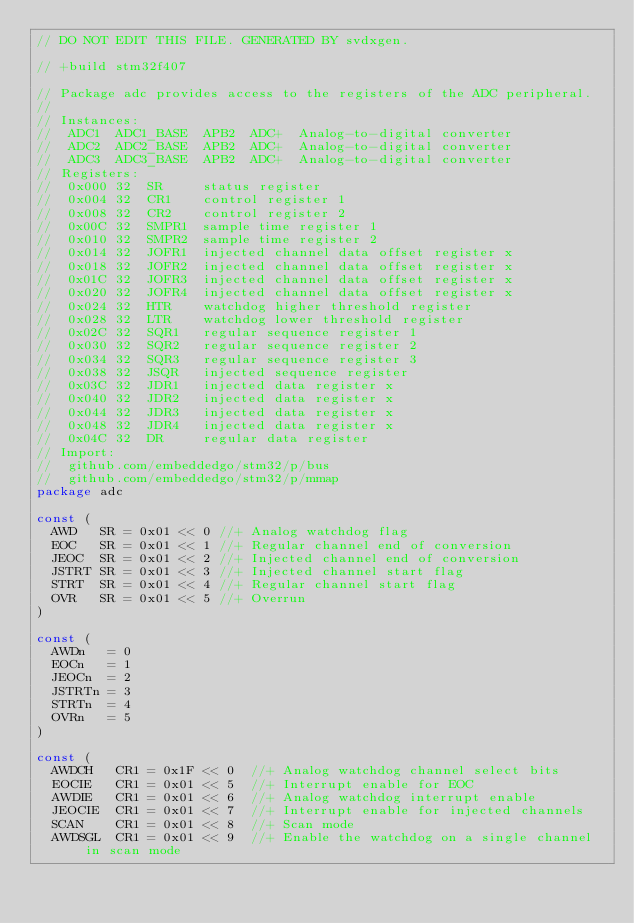Convert code to text. <code><loc_0><loc_0><loc_500><loc_500><_Go_>// DO NOT EDIT THIS FILE. GENERATED BY svdxgen.

// +build stm32f407

// Package adc provides access to the registers of the ADC peripheral.
//
// Instances:
//  ADC1  ADC1_BASE  APB2  ADC+  Analog-to-digital converter
//  ADC2  ADC2_BASE  APB2  ADC+  Analog-to-digital converter
//  ADC3  ADC3_BASE  APB2  ADC+  Analog-to-digital converter
// Registers:
//  0x000 32  SR     status register
//  0x004 32  CR1    control register 1
//  0x008 32  CR2    control register 2
//  0x00C 32  SMPR1  sample time register 1
//  0x010 32  SMPR2  sample time register 2
//  0x014 32  JOFR1  injected channel data offset register x
//  0x018 32  JOFR2  injected channel data offset register x
//  0x01C 32  JOFR3  injected channel data offset register x
//  0x020 32  JOFR4  injected channel data offset register x
//  0x024 32  HTR    watchdog higher threshold register
//  0x028 32  LTR    watchdog lower threshold register
//  0x02C 32  SQR1   regular sequence register 1
//  0x030 32  SQR2   regular sequence register 2
//  0x034 32  SQR3   regular sequence register 3
//  0x038 32  JSQR   injected sequence register
//  0x03C 32  JDR1   injected data register x
//  0x040 32  JDR2   injected data register x
//  0x044 32  JDR3   injected data register x
//  0x048 32  JDR4   injected data register x
//  0x04C 32  DR     regular data register
// Import:
//  github.com/embeddedgo/stm32/p/bus
//  github.com/embeddedgo/stm32/p/mmap
package adc

const (
	AWD   SR = 0x01 << 0 //+ Analog watchdog flag
	EOC   SR = 0x01 << 1 //+ Regular channel end of conversion
	JEOC  SR = 0x01 << 2 //+ Injected channel end of conversion
	JSTRT SR = 0x01 << 3 //+ Injected channel start flag
	STRT  SR = 0x01 << 4 //+ Regular channel start flag
	OVR   SR = 0x01 << 5 //+ Overrun
)

const (
	AWDn   = 0
	EOCn   = 1
	JEOCn  = 2
	JSTRTn = 3
	STRTn  = 4
	OVRn   = 5
)

const (
	AWDCH   CR1 = 0x1F << 0  //+ Analog watchdog channel select bits
	EOCIE   CR1 = 0x01 << 5  //+ Interrupt enable for EOC
	AWDIE   CR1 = 0x01 << 6  //+ Analog watchdog interrupt enable
	JEOCIE  CR1 = 0x01 << 7  //+ Interrupt enable for injected channels
	SCAN    CR1 = 0x01 << 8  //+ Scan mode
	AWDSGL  CR1 = 0x01 << 9  //+ Enable the watchdog on a single channel in scan mode</code> 